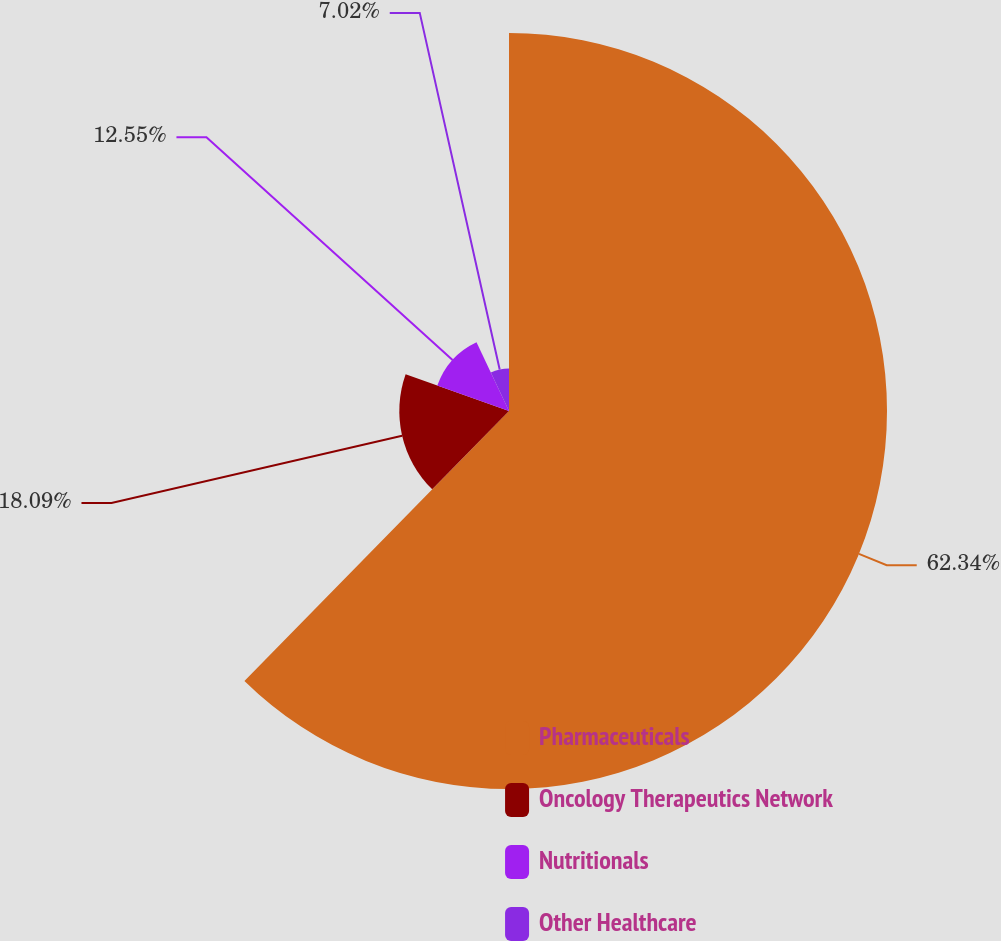Convert chart. <chart><loc_0><loc_0><loc_500><loc_500><pie_chart><fcel>Pharmaceuticals<fcel>Oncology Therapeutics Network<fcel>Nutritionals<fcel>Other Healthcare<nl><fcel>62.34%<fcel>18.09%<fcel>12.55%<fcel>7.02%<nl></chart> 